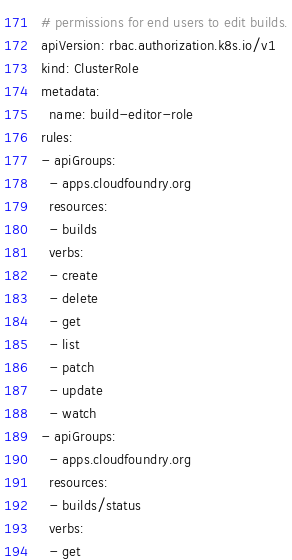Convert code to text. <code><loc_0><loc_0><loc_500><loc_500><_YAML_># permissions for end users to edit builds.
apiVersion: rbac.authorization.k8s.io/v1
kind: ClusterRole
metadata:
  name: build-editor-role
rules:
- apiGroups:
  - apps.cloudfoundry.org
  resources:
  - builds
  verbs:
  - create
  - delete
  - get
  - list
  - patch
  - update
  - watch
- apiGroups:
  - apps.cloudfoundry.org
  resources:
  - builds/status
  verbs:
  - get
</code> 